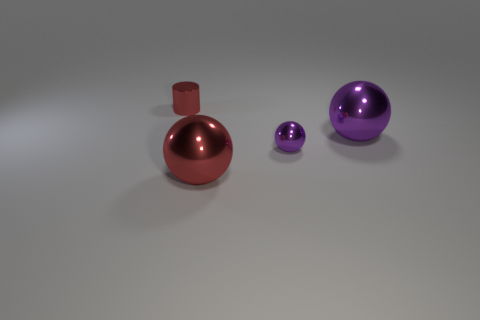Add 2 big red objects. How many objects exist? 6 Subtract all small spheres. How many spheres are left? 2 Subtract 1 balls. How many balls are left? 2 Subtract all red spheres. How many spheres are left? 2 Subtract all spheres. How many objects are left? 1 Subtract all yellow balls. Subtract all brown cylinders. How many balls are left? 3 Subtract all green cylinders. How many green balls are left? 0 Subtract all tiny gray shiny spheres. Subtract all purple balls. How many objects are left? 2 Add 1 big metallic objects. How many big metallic objects are left? 3 Add 2 tiny gray rubber blocks. How many tiny gray rubber blocks exist? 2 